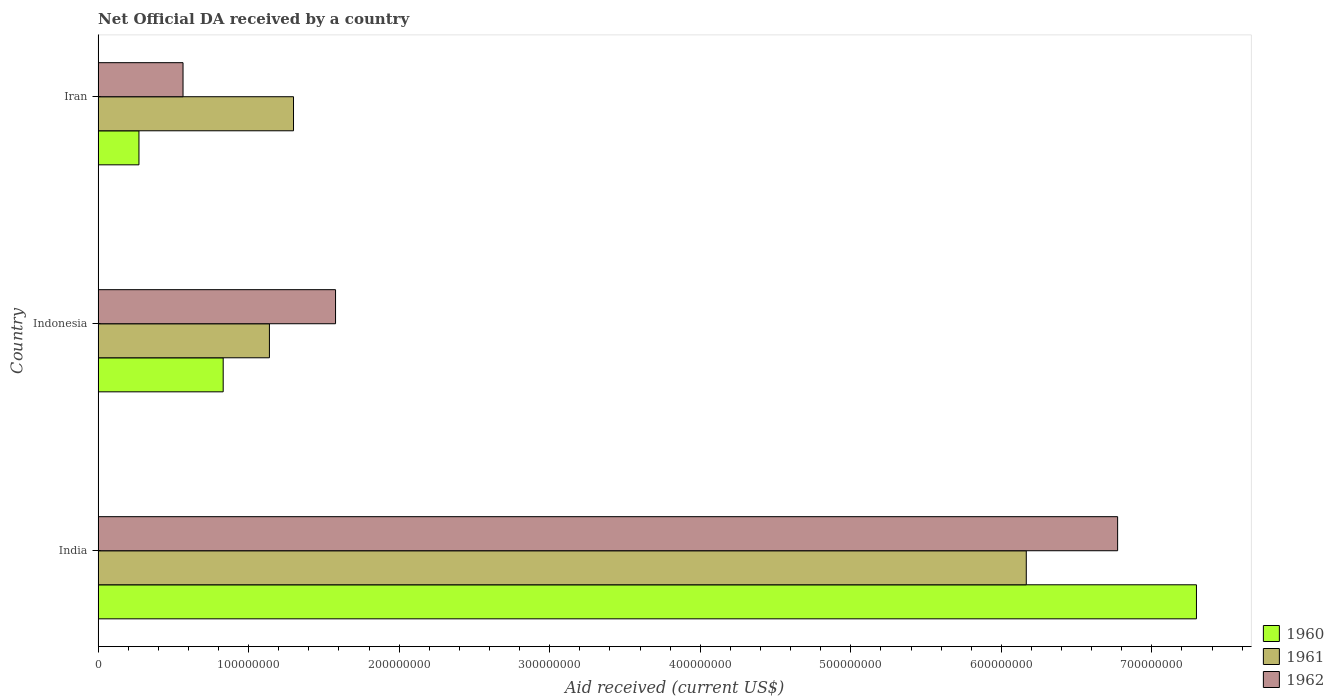Are the number of bars per tick equal to the number of legend labels?
Give a very brief answer. Yes. Are the number of bars on each tick of the Y-axis equal?
Ensure brevity in your answer.  Yes. What is the label of the 1st group of bars from the top?
Offer a terse response. Iran. What is the net official development assistance aid received in 1961 in Indonesia?
Provide a short and direct response. 1.14e+08. Across all countries, what is the maximum net official development assistance aid received in 1961?
Offer a very short reply. 6.17e+08. Across all countries, what is the minimum net official development assistance aid received in 1960?
Your answer should be very brief. 2.71e+07. In which country was the net official development assistance aid received in 1960 minimum?
Keep it short and to the point. Iran. What is the total net official development assistance aid received in 1960 in the graph?
Provide a short and direct response. 8.40e+08. What is the difference between the net official development assistance aid received in 1962 in India and that in Indonesia?
Ensure brevity in your answer.  5.20e+08. What is the difference between the net official development assistance aid received in 1962 in India and the net official development assistance aid received in 1960 in Indonesia?
Offer a very short reply. 5.94e+08. What is the average net official development assistance aid received in 1962 per country?
Ensure brevity in your answer.  2.97e+08. What is the difference between the net official development assistance aid received in 1961 and net official development assistance aid received in 1962 in Indonesia?
Offer a very short reply. -4.39e+07. In how many countries, is the net official development assistance aid received in 1962 greater than 540000000 US$?
Your answer should be very brief. 1. What is the ratio of the net official development assistance aid received in 1962 in India to that in Iran?
Offer a terse response. 12.01. Is the difference between the net official development assistance aid received in 1961 in India and Iran greater than the difference between the net official development assistance aid received in 1962 in India and Iran?
Your answer should be compact. No. What is the difference between the highest and the second highest net official development assistance aid received in 1962?
Your response must be concise. 5.20e+08. What is the difference between the highest and the lowest net official development assistance aid received in 1961?
Your answer should be compact. 5.03e+08. In how many countries, is the net official development assistance aid received in 1961 greater than the average net official development assistance aid received in 1961 taken over all countries?
Offer a terse response. 1. Is it the case that in every country, the sum of the net official development assistance aid received in 1962 and net official development assistance aid received in 1960 is greater than the net official development assistance aid received in 1961?
Your answer should be compact. No. How many bars are there?
Provide a succinct answer. 9. Are the values on the major ticks of X-axis written in scientific E-notation?
Provide a succinct answer. No. Does the graph contain grids?
Offer a terse response. No. How are the legend labels stacked?
Offer a very short reply. Vertical. What is the title of the graph?
Provide a succinct answer. Net Official DA received by a country. Does "1998" appear as one of the legend labels in the graph?
Your answer should be very brief. No. What is the label or title of the X-axis?
Your answer should be very brief. Aid received (current US$). What is the Aid received (current US$) in 1960 in India?
Your response must be concise. 7.30e+08. What is the Aid received (current US$) in 1961 in India?
Your response must be concise. 6.17e+08. What is the Aid received (current US$) of 1962 in India?
Your response must be concise. 6.77e+08. What is the Aid received (current US$) of 1960 in Indonesia?
Offer a very short reply. 8.31e+07. What is the Aid received (current US$) in 1961 in Indonesia?
Offer a terse response. 1.14e+08. What is the Aid received (current US$) in 1962 in Indonesia?
Your answer should be compact. 1.58e+08. What is the Aid received (current US$) in 1960 in Iran?
Offer a very short reply. 2.71e+07. What is the Aid received (current US$) of 1961 in Iran?
Ensure brevity in your answer.  1.30e+08. What is the Aid received (current US$) in 1962 in Iran?
Your response must be concise. 5.64e+07. Across all countries, what is the maximum Aid received (current US$) in 1960?
Make the answer very short. 7.30e+08. Across all countries, what is the maximum Aid received (current US$) of 1961?
Ensure brevity in your answer.  6.17e+08. Across all countries, what is the maximum Aid received (current US$) of 1962?
Your response must be concise. 6.77e+08. Across all countries, what is the minimum Aid received (current US$) of 1960?
Provide a short and direct response. 2.71e+07. Across all countries, what is the minimum Aid received (current US$) of 1961?
Your answer should be very brief. 1.14e+08. Across all countries, what is the minimum Aid received (current US$) in 1962?
Your answer should be very brief. 5.64e+07. What is the total Aid received (current US$) in 1960 in the graph?
Provide a short and direct response. 8.40e+08. What is the total Aid received (current US$) in 1961 in the graph?
Offer a very short reply. 8.60e+08. What is the total Aid received (current US$) of 1962 in the graph?
Ensure brevity in your answer.  8.91e+08. What is the difference between the Aid received (current US$) in 1960 in India and that in Indonesia?
Give a very brief answer. 6.47e+08. What is the difference between the Aid received (current US$) of 1961 in India and that in Indonesia?
Keep it short and to the point. 5.03e+08. What is the difference between the Aid received (current US$) of 1962 in India and that in Indonesia?
Provide a short and direct response. 5.20e+08. What is the difference between the Aid received (current US$) in 1960 in India and that in Iran?
Your response must be concise. 7.02e+08. What is the difference between the Aid received (current US$) in 1961 in India and that in Iran?
Your answer should be very brief. 4.87e+08. What is the difference between the Aid received (current US$) of 1962 in India and that in Iran?
Give a very brief answer. 6.21e+08. What is the difference between the Aid received (current US$) of 1960 in Indonesia and that in Iran?
Provide a succinct answer. 5.60e+07. What is the difference between the Aid received (current US$) of 1961 in Indonesia and that in Iran?
Keep it short and to the point. -1.60e+07. What is the difference between the Aid received (current US$) in 1962 in Indonesia and that in Iran?
Your response must be concise. 1.01e+08. What is the difference between the Aid received (current US$) of 1960 in India and the Aid received (current US$) of 1961 in Indonesia?
Keep it short and to the point. 6.16e+08. What is the difference between the Aid received (current US$) of 1960 in India and the Aid received (current US$) of 1962 in Indonesia?
Provide a succinct answer. 5.72e+08. What is the difference between the Aid received (current US$) of 1961 in India and the Aid received (current US$) of 1962 in Indonesia?
Provide a succinct answer. 4.59e+08. What is the difference between the Aid received (current US$) in 1960 in India and the Aid received (current US$) in 1961 in Iran?
Your answer should be compact. 6.00e+08. What is the difference between the Aid received (current US$) of 1960 in India and the Aid received (current US$) of 1962 in Iran?
Provide a succinct answer. 6.73e+08. What is the difference between the Aid received (current US$) in 1961 in India and the Aid received (current US$) in 1962 in Iran?
Give a very brief answer. 5.60e+08. What is the difference between the Aid received (current US$) of 1960 in Indonesia and the Aid received (current US$) of 1961 in Iran?
Your answer should be compact. -4.67e+07. What is the difference between the Aid received (current US$) of 1960 in Indonesia and the Aid received (current US$) of 1962 in Iran?
Offer a terse response. 2.67e+07. What is the difference between the Aid received (current US$) of 1961 in Indonesia and the Aid received (current US$) of 1962 in Iran?
Offer a very short reply. 5.74e+07. What is the average Aid received (current US$) in 1960 per country?
Offer a very short reply. 2.80e+08. What is the average Aid received (current US$) of 1961 per country?
Offer a very short reply. 2.87e+08. What is the average Aid received (current US$) of 1962 per country?
Your answer should be compact. 2.97e+08. What is the difference between the Aid received (current US$) in 1960 and Aid received (current US$) in 1961 in India?
Provide a short and direct response. 1.13e+08. What is the difference between the Aid received (current US$) in 1960 and Aid received (current US$) in 1962 in India?
Provide a short and direct response. 5.24e+07. What is the difference between the Aid received (current US$) of 1961 and Aid received (current US$) of 1962 in India?
Provide a succinct answer. -6.07e+07. What is the difference between the Aid received (current US$) of 1960 and Aid received (current US$) of 1961 in Indonesia?
Offer a very short reply. -3.07e+07. What is the difference between the Aid received (current US$) of 1960 and Aid received (current US$) of 1962 in Indonesia?
Keep it short and to the point. -7.46e+07. What is the difference between the Aid received (current US$) of 1961 and Aid received (current US$) of 1962 in Indonesia?
Offer a terse response. -4.39e+07. What is the difference between the Aid received (current US$) of 1960 and Aid received (current US$) of 1961 in Iran?
Keep it short and to the point. -1.03e+08. What is the difference between the Aid received (current US$) of 1960 and Aid received (current US$) of 1962 in Iran?
Offer a very short reply. -2.93e+07. What is the difference between the Aid received (current US$) in 1961 and Aid received (current US$) in 1962 in Iran?
Offer a terse response. 7.34e+07. What is the ratio of the Aid received (current US$) of 1960 in India to that in Indonesia?
Your answer should be very brief. 8.78. What is the ratio of the Aid received (current US$) of 1961 in India to that in Indonesia?
Your answer should be compact. 5.42. What is the ratio of the Aid received (current US$) of 1962 in India to that in Indonesia?
Make the answer very short. 4.29. What is the ratio of the Aid received (current US$) of 1960 in India to that in Iran?
Make the answer very short. 26.89. What is the ratio of the Aid received (current US$) in 1961 in India to that in Iran?
Offer a terse response. 4.75. What is the ratio of the Aid received (current US$) of 1962 in India to that in Iran?
Provide a succinct answer. 12.01. What is the ratio of the Aid received (current US$) in 1960 in Indonesia to that in Iran?
Give a very brief answer. 3.06. What is the ratio of the Aid received (current US$) of 1961 in Indonesia to that in Iran?
Keep it short and to the point. 0.88. What is the ratio of the Aid received (current US$) in 1962 in Indonesia to that in Iran?
Make the answer very short. 2.8. What is the difference between the highest and the second highest Aid received (current US$) of 1960?
Your answer should be compact. 6.47e+08. What is the difference between the highest and the second highest Aid received (current US$) of 1961?
Keep it short and to the point. 4.87e+08. What is the difference between the highest and the second highest Aid received (current US$) in 1962?
Make the answer very short. 5.20e+08. What is the difference between the highest and the lowest Aid received (current US$) of 1960?
Your answer should be compact. 7.02e+08. What is the difference between the highest and the lowest Aid received (current US$) of 1961?
Offer a terse response. 5.03e+08. What is the difference between the highest and the lowest Aid received (current US$) in 1962?
Your answer should be very brief. 6.21e+08. 